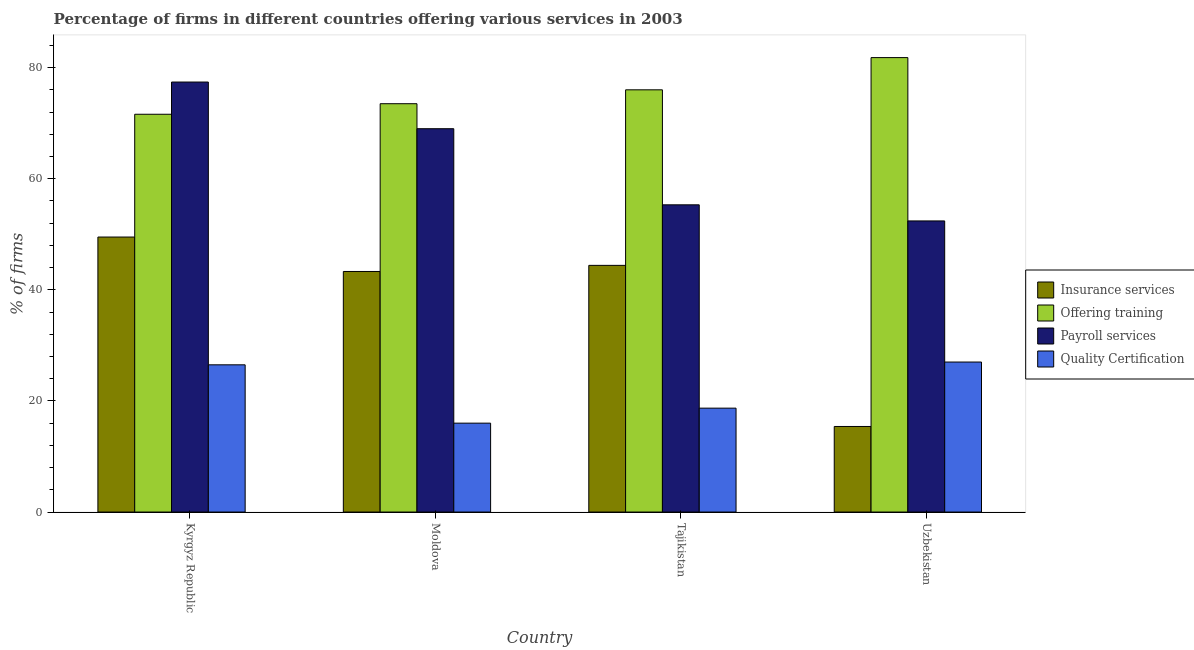How many different coloured bars are there?
Your answer should be very brief. 4. What is the label of the 4th group of bars from the left?
Keep it short and to the point. Uzbekistan. What is the percentage of firms offering quality certification in Tajikistan?
Offer a terse response. 18.7. Across all countries, what is the maximum percentage of firms offering quality certification?
Your response must be concise. 27. Across all countries, what is the minimum percentage of firms offering training?
Your answer should be compact. 71.6. In which country was the percentage of firms offering insurance services maximum?
Provide a short and direct response. Kyrgyz Republic. In which country was the percentage of firms offering insurance services minimum?
Offer a terse response. Uzbekistan. What is the total percentage of firms offering training in the graph?
Offer a terse response. 302.9. What is the difference between the percentage of firms offering payroll services in Kyrgyz Republic and that in Uzbekistan?
Your response must be concise. 25. What is the difference between the percentage of firms offering payroll services in Moldova and the percentage of firms offering training in Uzbekistan?
Ensure brevity in your answer.  -12.8. What is the average percentage of firms offering quality certification per country?
Offer a terse response. 22.05. What is the difference between the percentage of firms offering quality certification and percentage of firms offering payroll services in Uzbekistan?
Make the answer very short. -25.4. In how many countries, is the percentage of firms offering payroll services greater than 8 %?
Provide a succinct answer. 4. What is the ratio of the percentage of firms offering payroll services in Moldova to that in Uzbekistan?
Make the answer very short. 1.32. What is the difference between the highest and the second highest percentage of firms offering insurance services?
Ensure brevity in your answer.  5.1. What is the difference between the highest and the lowest percentage of firms offering insurance services?
Make the answer very short. 34.1. In how many countries, is the percentage of firms offering payroll services greater than the average percentage of firms offering payroll services taken over all countries?
Your answer should be compact. 2. Is the sum of the percentage of firms offering insurance services in Tajikistan and Uzbekistan greater than the maximum percentage of firms offering payroll services across all countries?
Keep it short and to the point. No. Is it the case that in every country, the sum of the percentage of firms offering quality certification and percentage of firms offering insurance services is greater than the sum of percentage of firms offering payroll services and percentage of firms offering training?
Keep it short and to the point. No. What does the 3rd bar from the left in Moldova represents?
Ensure brevity in your answer.  Payroll services. What does the 2nd bar from the right in Moldova represents?
Offer a terse response. Payroll services. Is it the case that in every country, the sum of the percentage of firms offering insurance services and percentage of firms offering training is greater than the percentage of firms offering payroll services?
Your answer should be very brief. Yes. How many bars are there?
Give a very brief answer. 16. Are all the bars in the graph horizontal?
Give a very brief answer. No. How many countries are there in the graph?
Make the answer very short. 4. What is the difference between two consecutive major ticks on the Y-axis?
Make the answer very short. 20. Does the graph contain any zero values?
Your answer should be very brief. No. Where does the legend appear in the graph?
Give a very brief answer. Center right. How are the legend labels stacked?
Your answer should be very brief. Vertical. What is the title of the graph?
Your response must be concise. Percentage of firms in different countries offering various services in 2003. What is the label or title of the Y-axis?
Provide a short and direct response. % of firms. What is the % of firms of Insurance services in Kyrgyz Republic?
Provide a short and direct response. 49.5. What is the % of firms of Offering training in Kyrgyz Republic?
Offer a terse response. 71.6. What is the % of firms in Payroll services in Kyrgyz Republic?
Provide a short and direct response. 77.4. What is the % of firms in Quality Certification in Kyrgyz Republic?
Your answer should be very brief. 26.5. What is the % of firms of Insurance services in Moldova?
Ensure brevity in your answer.  43.3. What is the % of firms of Offering training in Moldova?
Your answer should be compact. 73.5. What is the % of firms in Insurance services in Tajikistan?
Your response must be concise. 44.4. What is the % of firms in Payroll services in Tajikistan?
Give a very brief answer. 55.3. What is the % of firms of Insurance services in Uzbekistan?
Make the answer very short. 15.4. What is the % of firms of Offering training in Uzbekistan?
Provide a short and direct response. 81.8. What is the % of firms of Payroll services in Uzbekistan?
Your response must be concise. 52.4. Across all countries, what is the maximum % of firms in Insurance services?
Ensure brevity in your answer.  49.5. Across all countries, what is the maximum % of firms in Offering training?
Offer a terse response. 81.8. Across all countries, what is the maximum % of firms in Payroll services?
Provide a succinct answer. 77.4. Across all countries, what is the minimum % of firms of Insurance services?
Provide a short and direct response. 15.4. Across all countries, what is the minimum % of firms of Offering training?
Give a very brief answer. 71.6. Across all countries, what is the minimum % of firms of Payroll services?
Offer a terse response. 52.4. What is the total % of firms in Insurance services in the graph?
Offer a terse response. 152.6. What is the total % of firms of Offering training in the graph?
Ensure brevity in your answer.  302.9. What is the total % of firms in Payroll services in the graph?
Keep it short and to the point. 254.1. What is the total % of firms of Quality Certification in the graph?
Your answer should be very brief. 88.2. What is the difference between the % of firms in Insurance services in Kyrgyz Republic and that in Moldova?
Make the answer very short. 6.2. What is the difference between the % of firms of Payroll services in Kyrgyz Republic and that in Moldova?
Offer a terse response. 8.4. What is the difference between the % of firms of Offering training in Kyrgyz Republic and that in Tajikistan?
Offer a very short reply. -4.4. What is the difference between the % of firms in Payroll services in Kyrgyz Republic and that in Tajikistan?
Give a very brief answer. 22.1. What is the difference between the % of firms in Insurance services in Kyrgyz Republic and that in Uzbekistan?
Ensure brevity in your answer.  34.1. What is the difference between the % of firms of Offering training in Kyrgyz Republic and that in Uzbekistan?
Make the answer very short. -10.2. What is the difference between the % of firms in Offering training in Moldova and that in Tajikistan?
Provide a short and direct response. -2.5. What is the difference between the % of firms in Insurance services in Moldova and that in Uzbekistan?
Provide a succinct answer. 27.9. What is the difference between the % of firms of Insurance services in Tajikistan and that in Uzbekistan?
Your answer should be very brief. 29. What is the difference between the % of firms of Offering training in Tajikistan and that in Uzbekistan?
Offer a terse response. -5.8. What is the difference between the % of firms in Payroll services in Tajikistan and that in Uzbekistan?
Keep it short and to the point. 2.9. What is the difference between the % of firms of Insurance services in Kyrgyz Republic and the % of firms of Offering training in Moldova?
Offer a terse response. -24. What is the difference between the % of firms in Insurance services in Kyrgyz Republic and the % of firms in Payroll services in Moldova?
Offer a terse response. -19.5. What is the difference between the % of firms in Insurance services in Kyrgyz Republic and the % of firms in Quality Certification in Moldova?
Provide a succinct answer. 33.5. What is the difference between the % of firms of Offering training in Kyrgyz Republic and the % of firms of Payroll services in Moldova?
Keep it short and to the point. 2.6. What is the difference between the % of firms of Offering training in Kyrgyz Republic and the % of firms of Quality Certification in Moldova?
Keep it short and to the point. 55.6. What is the difference between the % of firms in Payroll services in Kyrgyz Republic and the % of firms in Quality Certification in Moldova?
Give a very brief answer. 61.4. What is the difference between the % of firms of Insurance services in Kyrgyz Republic and the % of firms of Offering training in Tajikistan?
Make the answer very short. -26.5. What is the difference between the % of firms in Insurance services in Kyrgyz Republic and the % of firms in Quality Certification in Tajikistan?
Provide a succinct answer. 30.8. What is the difference between the % of firms in Offering training in Kyrgyz Republic and the % of firms in Payroll services in Tajikistan?
Ensure brevity in your answer.  16.3. What is the difference between the % of firms of Offering training in Kyrgyz Republic and the % of firms of Quality Certification in Tajikistan?
Ensure brevity in your answer.  52.9. What is the difference between the % of firms of Payroll services in Kyrgyz Republic and the % of firms of Quality Certification in Tajikistan?
Provide a short and direct response. 58.7. What is the difference between the % of firms in Insurance services in Kyrgyz Republic and the % of firms in Offering training in Uzbekistan?
Your answer should be very brief. -32.3. What is the difference between the % of firms in Offering training in Kyrgyz Republic and the % of firms in Quality Certification in Uzbekistan?
Provide a short and direct response. 44.6. What is the difference between the % of firms in Payroll services in Kyrgyz Republic and the % of firms in Quality Certification in Uzbekistan?
Offer a terse response. 50.4. What is the difference between the % of firms of Insurance services in Moldova and the % of firms of Offering training in Tajikistan?
Give a very brief answer. -32.7. What is the difference between the % of firms in Insurance services in Moldova and the % of firms in Quality Certification in Tajikistan?
Ensure brevity in your answer.  24.6. What is the difference between the % of firms in Offering training in Moldova and the % of firms in Payroll services in Tajikistan?
Keep it short and to the point. 18.2. What is the difference between the % of firms in Offering training in Moldova and the % of firms in Quality Certification in Tajikistan?
Offer a terse response. 54.8. What is the difference between the % of firms of Payroll services in Moldova and the % of firms of Quality Certification in Tajikistan?
Provide a succinct answer. 50.3. What is the difference between the % of firms in Insurance services in Moldova and the % of firms in Offering training in Uzbekistan?
Your answer should be very brief. -38.5. What is the difference between the % of firms in Insurance services in Moldova and the % of firms in Payroll services in Uzbekistan?
Your answer should be very brief. -9.1. What is the difference between the % of firms in Insurance services in Moldova and the % of firms in Quality Certification in Uzbekistan?
Ensure brevity in your answer.  16.3. What is the difference between the % of firms in Offering training in Moldova and the % of firms in Payroll services in Uzbekistan?
Your response must be concise. 21.1. What is the difference between the % of firms of Offering training in Moldova and the % of firms of Quality Certification in Uzbekistan?
Offer a very short reply. 46.5. What is the difference between the % of firms in Insurance services in Tajikistan and the % of firms in Offering training in Uzbekistan?
Your answer should be compact. -37.4. What is the difference between the % of firms of Insurance services in Tajikistan and the % of firms of Payroll services in Uzbekistan?
Offer a terse response. -8. What is the difference between the % of firms in Insurance services in Tajikistan and the % of firms in Quality Certification in Uzbekistan?
Make the answer very short. 17.4. What is the difference between the % of firms in Offering training in Tajikistan and the % of firms in Payroll services in Uzbekistan?
Your response must be concise. 23.6. What is the difference between the % of firms of Offering training in Tajikistan and the % of firms of Quality Certification in Uzbekistan?
Provide a short and direct response. 49. What is the difference between the % of firms of Payroll services in Tajikistan and the % of firms of Quality Certification in Uzbekistan?
Your answer should be compact. 28.3. What is the average % of firms in Insurance services per country?
Your answer should be compact. 38.15. What is the average % of firms of Offering training per country?
Your answer should be compact. 75.72. What is the average % of firms in Payroll services per country?
Make the answer very short. 63.52. What is the average % of firms in Quality Certification per country?
Provide a short and direct response. 22.05. What is the difference between the % of firms of Insurance services and % of firms of Offering training in Kyrgyz Republic?
Keep it short and to the point. -22.1. What is the difference between the % of firms in Insurance services and % of firms in Payroll services in Kyrgyz Republic?
Make the answer very short. -27.9. What is the difference between the % of firms of Offering training and % of firms of Payroll services in Kyrgyz Republic?
Give a very brief answer. -5.8. What is the difference between the % of firms of Offering training and % of firms of Quality Certification in Kyrgyz Republic?
Give a very brief answer. 45.1. What is the difference between the % of firms in Payroll services and % of firms in Quality Certification in Kyrgyz Republic?
Your response must be concise. 50.9. What is the difference between the % of firms in Insurance services and % of firms in Offering training in Moldova?
Your answer should be very brief. -30.2. What is the difference between the % of firms in Insurance services and % of firms in Payroll services in Moldova?
Offer a very short reply. -25.7. What is the difference between the % of firms of Insurance services and % of firms of Quality Certification in Moldova?
Your response must be concise. 27.3. What is the difference between the % of firms in Offering training and % of firms in Quality Certification in Moldova?
Make the answer very short. 57.5. What is the difference between the % of firms in Payroll services and % of firms in Quality Certification in Moldova?
Your answer should be very brief. 53. What is the difference between the % of firms in Insurance services and % of firms in Offering training in Tajikistan?
Provide a succinct answer. -31.6. What is the difference between the % of firms of Insurance services and % of firms of Payroll services in Tajikistan?
Provide a succinct answer. -10.9. What is the difference between the % of firms in Insurance services and % of firms in Quality Certification in Tajikistan?
Make the answer very short. 25.7. What is the difference between the % of firms in Offering training and % of firms in Payroll services in Tajikistan?
Provide a succinct answer. 20.7. What is the difference between the % of firms in Offering training and % of firms in Quality Certification in Tajikistan?
Offer a terse response. 57.3. What is the difference between the % of firms in Payroll services and % of firms in Quality Certification in Tajikistan?
Offer a very short reply. 36.6. What is the difference between the % of firms in Insurance services and % of firms in Offering training in Uzbekistan?
Make the answer very short. -66.4. What is the difference between the % of firms of Insurance services and % of firms of Payroll services in Uzbekistan?
Ensure brevity in your answer.  -37. What is the difference between the % of firms of Insurance services and % of firms of Quality Certification in Uzbekistan?
Your answer should be very brief. -11.6. What is the difference between the % of firms in Offering training and % of firms in Payroll services in Uzbekistan?
Make the answer very short. 29.4. What is the difference between the % of firms of Offering training and % of firms of Quality Certification in Uzbekistan?
Give a very brief answer. 54.8. What is the difference between the % of firms of Payroll services and % of firms of Quality Certification in Uzbekistan?
Your response must be concise. 25.4. What is the ratio of the % of firms of Insurance services in Kyrgyz Republic to that in Moldova?
Your answer should be compact. 1.14. What is the ratio of the % of firms in Offering training in Kyrgyz Republic to that in Moldova?
Provide a succinct answer. 0.97. What is the ratio of the % of firms in Payroll services in Kyrgyz Republic to that in Moldova?
Provide a succinct answer. 1.12. What is the ratio of the % of firms of Quality Certification in Kyrgyz Republic to that in Moldova?
Provide a succinct answer. 1.66. What is the ratio of the % of firms in Insurance services in Kyrgyz Republic to that in Tajikistan?
Offer a very short reply. 1.11. What is the ratio of the % of firms in Offering training in Kyrgyz Republic to that in Tajikistan?
Offer a very short reply. 0.94. What is the ratio of the % of firms of Payroll services in Kyrgyz Republic to that in Tajikistan?
Provide a short and direct response. 1.4. What is the ratio of the % of firms in Quality Certification in Kyrgyz Republic to that in Tajikistan?
Offer a terse response. 1.42. What is the ratio of the % of firms in Insurance services in Kyrgyz Republic to that in Uzbekistan?
Make the answer very short. 3.21. What is the ratio of the % of firms of Offering training in Kyrgyz Republic to that in Uzbekistan?
Keep it short and to the point. 0.88. What is the ratio of the % of firms of Payroll services in Kyrgyz Republic to that in Uzbekistan?
Ensure brevity in your answer.  1.48. What is the ratio of the % of firms of Quality Certification in Kyrgyz Republic to that in Uzbekistan?
Give a very brief answer. 0.98. What is the ratio of the % of firms in Insurance services in Moldova to that in Tajikistan?
Make the answer very short. 0.98. What is the ratio of the % of firms of Offering training in Moldova to that in Tajikistan?
Provide a short and direct response. 0.97. What is the ratio of the % of firms of Payroll services in Moldova to that in Tajikistan?
Provide a short and direct response. 1.25. What is the ratio of the % of firms of Quality Certification in Moldova to that in Tajikistan?
Your answer should be compact. 0.86. What is the ratio of the % of firms in Insurance services in Moldova to that in Uzbekistan?
Provide a succinct answer. 2.81. What is the ratio of the % of firms of Offering training in Moldova to that in Uzbekistan?
Your response must be concise. 0.9. What is the ratio of the % of firms of Payroll services in Moldova to that in Uzbekistan?
Your response must be concise. 1.32. What is the ratio of the % of firms of Quality Certification in Moldova to that in Uzbekistan?
Provide a short and direct response. 0.59. What is the ratio of the % of firms of Insurance services in Tajikistan to that in Uzbekistan?
Your response must be concise. 2.88. What is the ratio of the % of firms in Offering training in Tajikistan to that in Uzbekistan?
Offer a terse response. 0.93. What is the ratio of the % of firms of Payroll services in Tajikistan to that in Uzbekistan?
Your answer should be very brief. 1.06. What is the ratio of the % of firms in Quality Certification in Tajikistan to that in Uzbekistan?
Your answer should be very brief. 0.69. What is the difference between the highest and the second highest % of firms of Quality Certification?
Your answer should be compact. 0.5. What is the difference between the highest and the lowest % of firms in Insurance services?
Keep it short and to the point. 34.1. What is the difference between the highest and the lowest % of firms of Offering training?
Provide a succinct answer. 10.2. What is the difference between the highest and the lowest % of firms in Payroll services?
Keep it short and to the point. 25. What is the difference between the highest and the lowest % of firms of Quality Certification?
Ensure brevity in your answer.  11. 